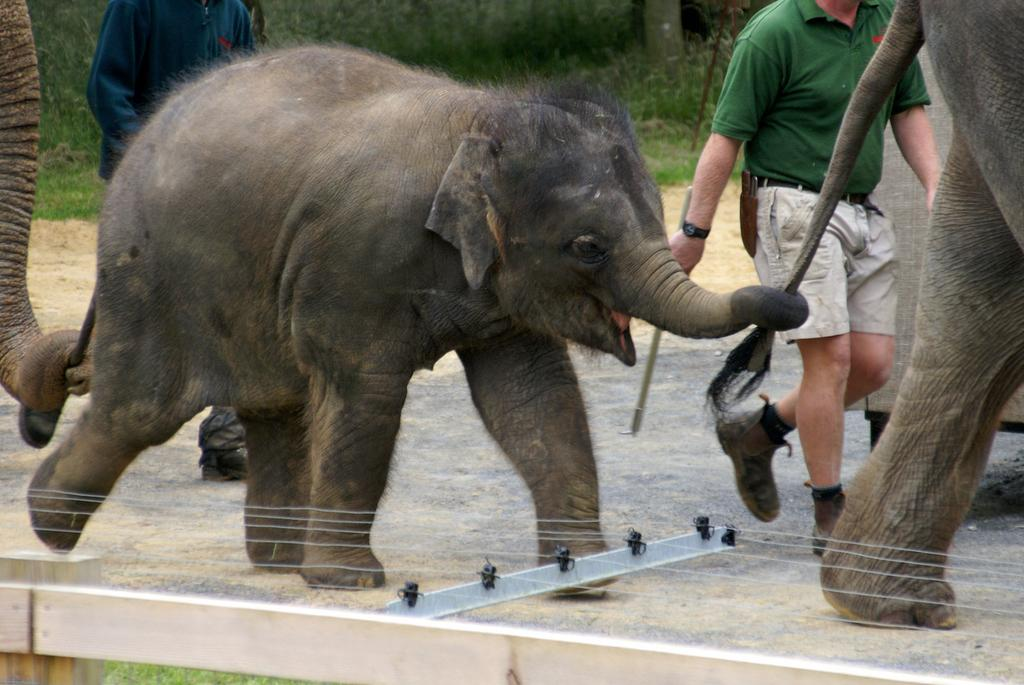What animals are present in the image? There are elephants in the image. Who else is present in the image besides the elephants? There are people in the image. Where are the elephants and people located in the image? The elephants and people are on the ground. What can be seen in the background of the image? There are trees in the background of the image. What type of notebook is being used by the elephants to solve arithmetic problems in the image? There is no notebook or arithmetic problem present in the image; it features elephants and people on the ground with trees in the background. 